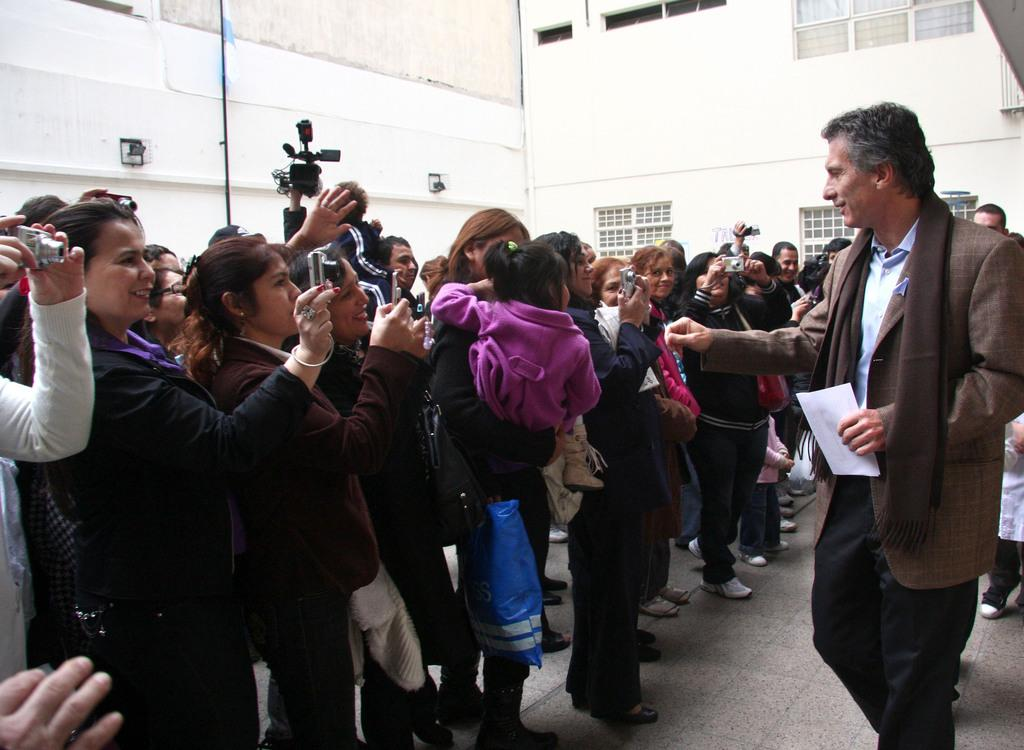What are the people in the image doing? The people in the image are standing and holding cameras. Is there anyone in the image not holding a camera? Yes, there is a man standing and holding a paper. What can be seen in the background of the image? There are walls and windows in the background of the image. How many grapes are being held by the people in the image? There are no grapes present in the image; the people are holding cameras and a paper. What type of umbrella is being used by the people in the image? There is no umbrella present in the image. 